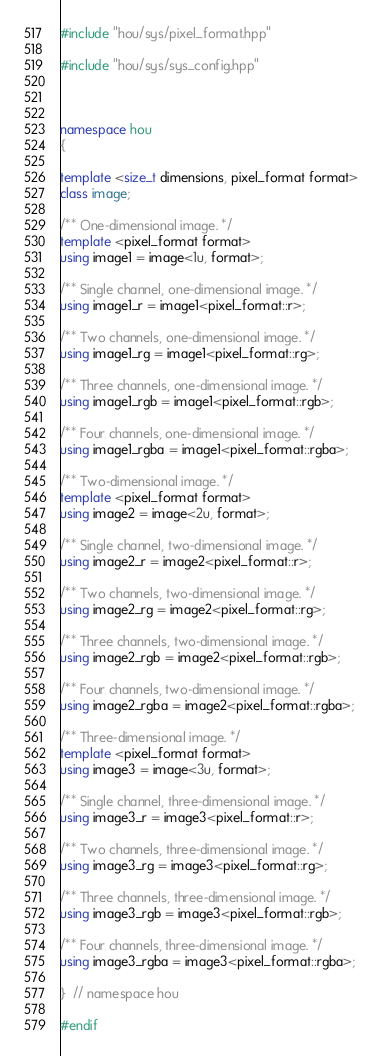Convert code to text. <code><loc_0><loc_0><loc_500><loc_500><_C++_>#include "hou/sys/pixel_format.hpp"

#include "hou/sys/sys_config.hpp"



namespace hou
{

template <size_t dimensions, pixel_format format>
class image;

/** One-dimensional image. */
template <pixel_format format>
using image1 = image<1u, format>;

/** Single channel, one-dimensional image. */
using image1_r = image1<pixel_format::r>;

/** Two channels, one-dimensional image. */
using image1_rg = image1<pixel_format::rg>;

/** Three channels, one-dimensional image. */
using image1_rgb = image1<pixel_format::rgb>;

/** Four channels, one-dimensional image. */
using image1_rgba = image1<pixel_format::rgba>;

/** Two-dimensional image. */
template <pixel_format format>
using image2 = image<2u, format>;

/** Single channel, two-dimensional image. */
using image2_r = image2<pixel_format::r>;

/** Two channels, two-dimensional image. */
using image2_rg = image2<pixel_format::rg>;

/** Three channels, two-dimensional image. */
using image2_rgb = image2<pixel_format::rgb>;

/** Four channels, two-dimensional image. */
using image2_rgba = image2<pixel_format::rgba>;

/** Three-dimensional image. */
template <pixel_format format>
using image3 = image<3u, format>;

/** Single channel, three-dimensional image. */
using image3_r = image3<pixel_format::r>;

/** Two channels, three-dimensional image. */
using image3_rg = image3<pixel_format::rg>;

/** Three channels, three-dimensional image. */
using image3_rgb = image3<pixel_format::rgb>;

/** Four channels, three-dimensional image. */
using image3_rgba = image3<pixel_format::rgba>;

}  // namespace hou

#endif
</code> 